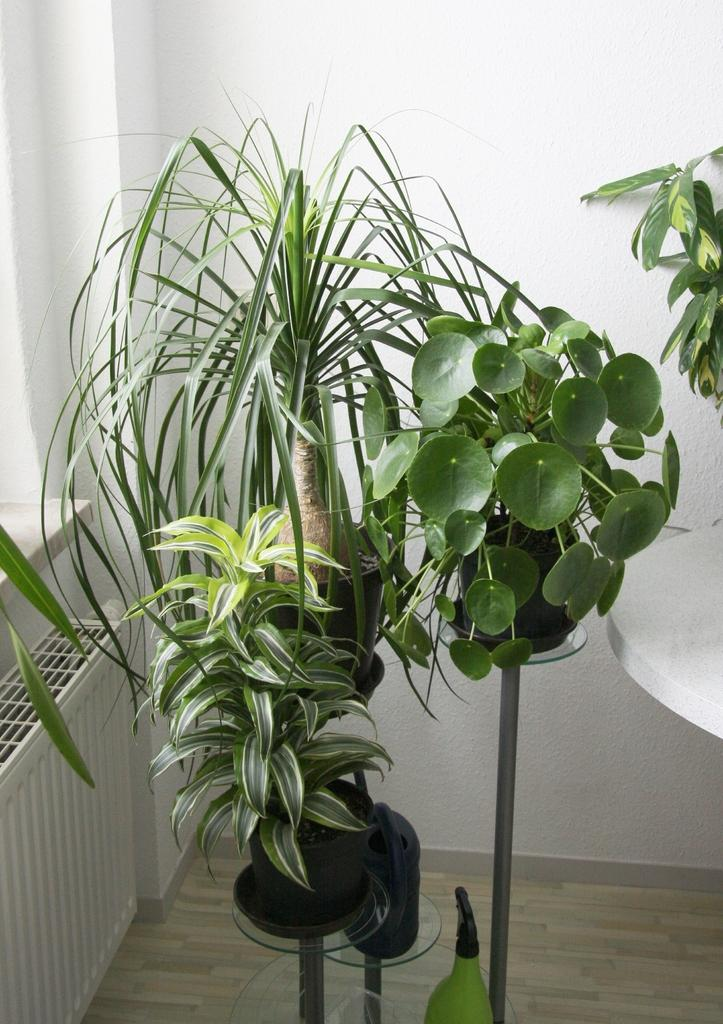What type of living organism can be seen in the house? There is a plant in the house. Where is the plant located in the house? The plant is placed on the floor. What can be seen on the wall in the image? There is a wall in the image. What is visible through the window in the image? There is a window in the image. What type of grain is being harvested by the tiger in the image? There is no tiger or grain present in the image. 